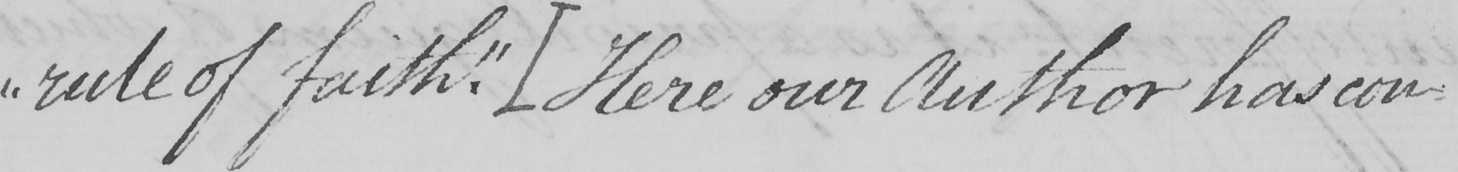Can you tell me what this handwritten text says? " rule of faith . "   [ Here our Author has con- 